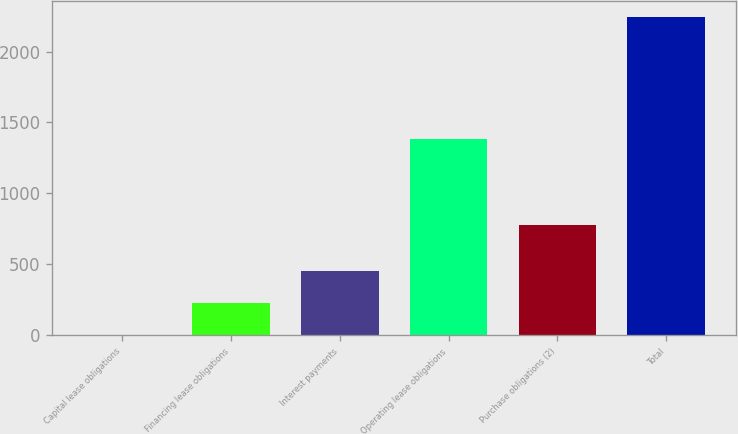Convert chart to OTSL. <chart><loc_0><loc_0><loc_500><loc_500><bar_chart><fcel>Capital lease obligations<fcel>Financing lease obligations<fcel>Interest payments<fcel>Operating lease obligations<fcel>Purchase obligations (2)<fcel>Total<nl><fcel>6<fcel>229.9<fcel>453.8<fcel>1387<fcel>775<fcel>2245<nl></chart> 